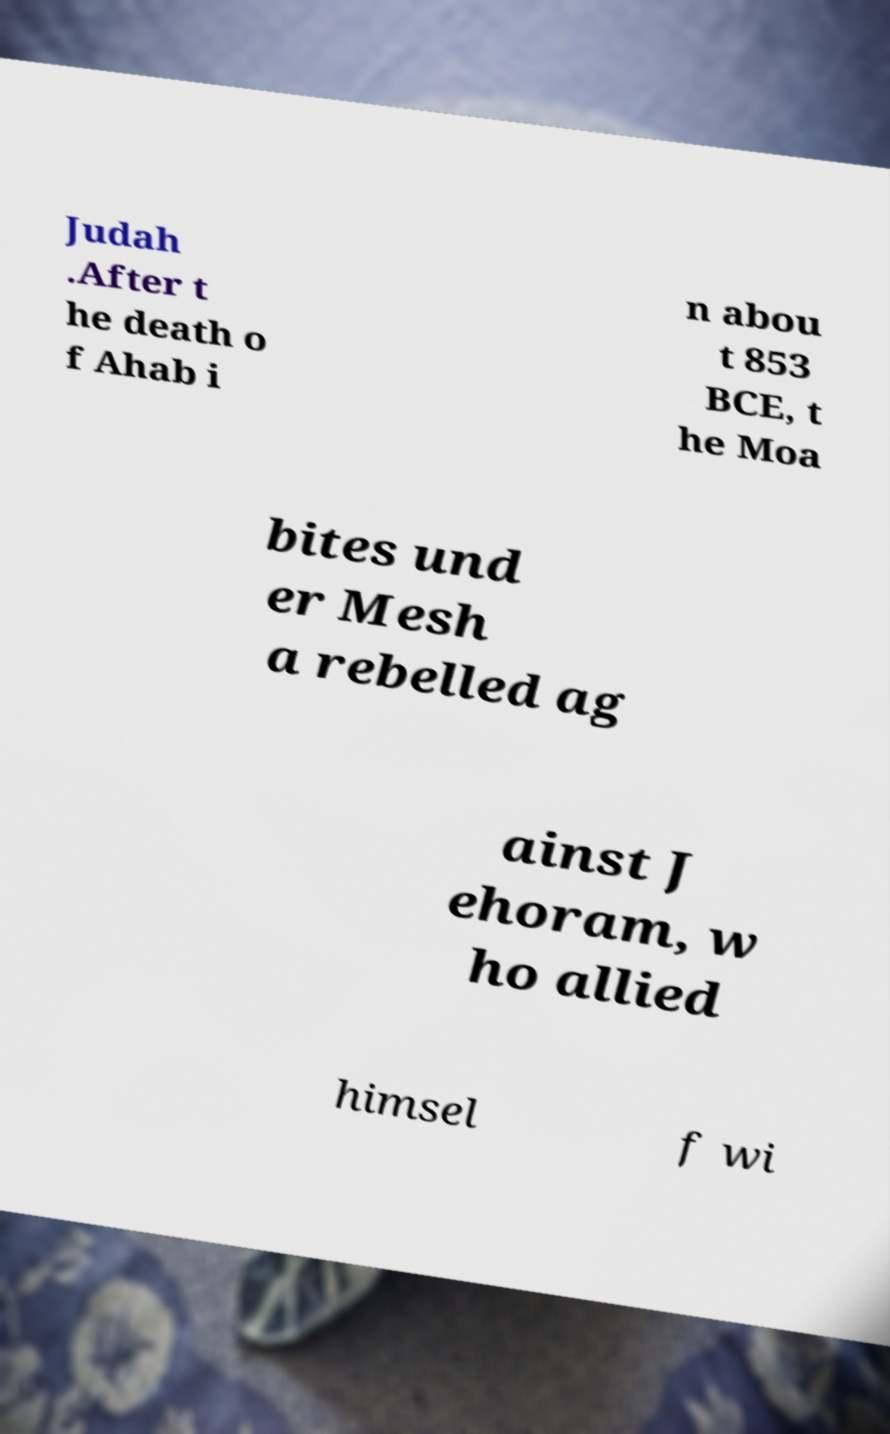Could you assist in decoding the text presented in this image and type it out clearly? Judah .After t he death o f Ahab i n abou t 853 BCE, t he Moa bites und er Mesh a rebelled ag ainst J ehoram, w ho allied himsel f wi 